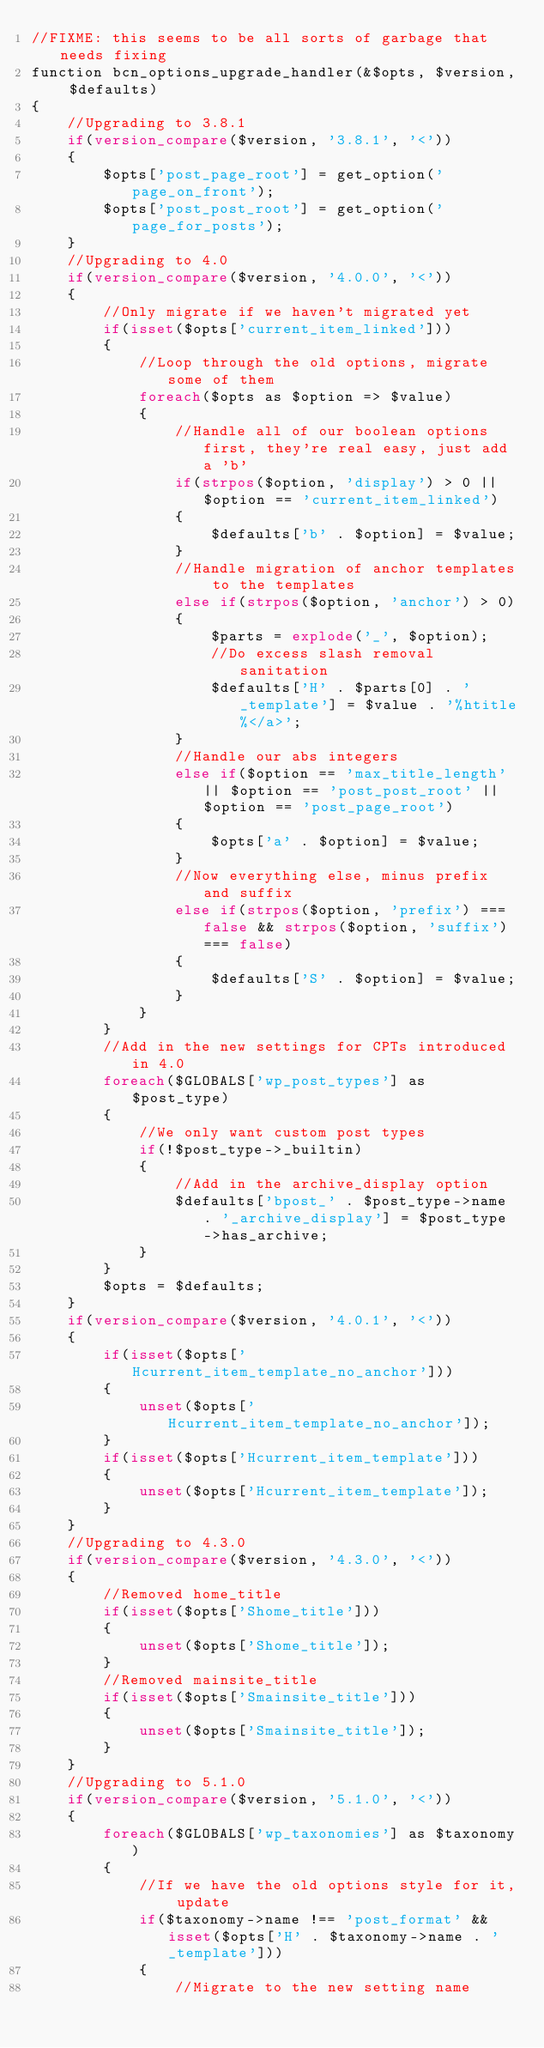<code> <loc_0><loc_0><loc_500><loc_500><_PHP_>//FIXME: this seems to be all sorts of garbage that needs fixing
function bcn_options_upgrade_handler(&$opts, $version, $defaults)
{
	//Upgrading to 3.8.1
	if(version_compare($version, '3.8.1', '<'))
	{
		$opts['post_page_root'] = get_option('page_on_front');
		$opts['post_post_root'] = get_option('page_for_posts');
	}
	//Upgrading to 4.0
	if(version_compare($version, '4.0.0', '<'))
	{
		//Only migrate if we haven't migrated yet
		if(isset($opts['current_item_linked']))
		{
			//Loop through the old options, migrate some of them
			foreach($opts as $option => $value)
			{
				//Handle all of our boolean options first, they're real easy, just add a 'b'
				if(strpos($option, 'display') > 0 || $option == 'current_item_linked')
				{
					$defaults['b' . $option] = $value;
				}
				//Handle migration of anchor templates to the templates
				else if(strpos($option, 'anchor') > 0)
				{
					$parts = explode('_', $option);
					//Do excess slash removal sanitation
					$defaults['H' . $parts[0] . '_template'] = $value . '%htitle%</a>';
				}
				//Handle our abs integers
				else if($option == 'max_title_length' || $option == 'post_post_root' || $option == 'post_page_root')
				{
					$opts['a' . $option] = $value;
				}
				//Now everything else, minus prefix and suffix
				else if(strpos($option, 'prefix') === false && strpos($option, 'suffix') === false)
				{
					$defaults['S' . $option] = $value;
				}
			}
		}
		//Add in the new settings for CPTs introduced in 4.0
		foreach($GLOBALS['wp_post_types'] as $post_type)
		{
			//We only want custom post types
			if(!$post_type->_builtin)
			{
				//Add in the archive_display option
				$defaults['bpost_' . $post_type->name . '_archive_display'] = $post_type->has_archive;
			}
		}
		$opts = $defaults;
	}
	if(version_compare($version, '4.0.1', '<'))
	{
		if(isset($opts['Hcurrent_item_template_no_anchor']))
		{
			unset($opts['Hcurrent_item_template_no_anchor']);
		}
		if(isset($opts['Hcurrent_item_template']))
		{
			unset($opts['Hcurrent_item_template']);
		}
	}
	//Upgrading to 4.3.0
	if(version_compare($version, '4.3.0', '<'))
	{
		//Removed home_title
		if(isset($opts['Shome_title']))
		{
			unset($opts['Shome_title']);
		}
		//Removed mainsite_title
		if(isset($opts['Smainsite_title']))
		{
			unset($opts['Smainsite_title']);
		}
	}
	//Upgrading to 5.1.0
	if(version_compare($version, '5.1.0', '<'))
	{
		foreach($GLOBALS['wp_taxonomies'] as $taxonomy)
		{
			//If we have the old options style for it, update
			if($taxonomy->name !== 'post_format' && isset($opts['H' . $taxonomy->name . '_template']))
			{
				//Migrate to the new setting name</code> 